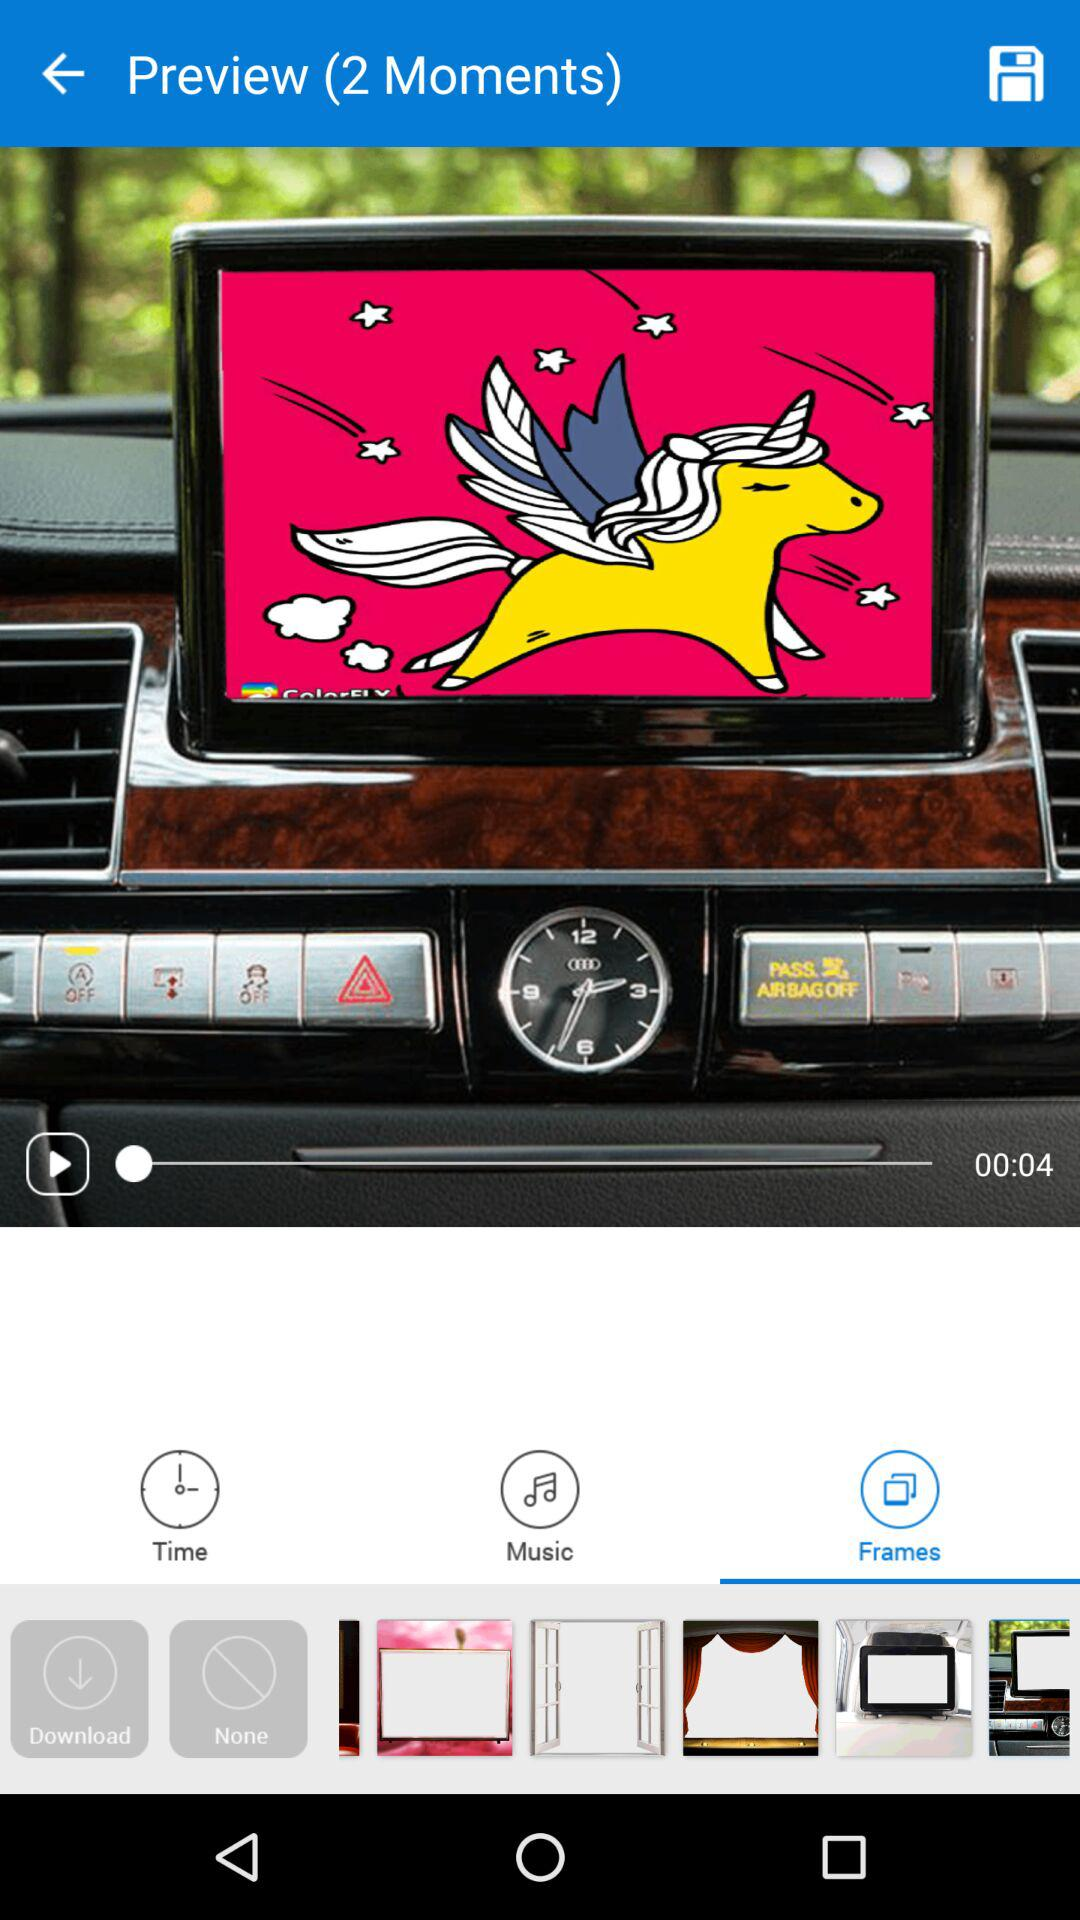Which tab is selected? The selected tab is "Frames". 